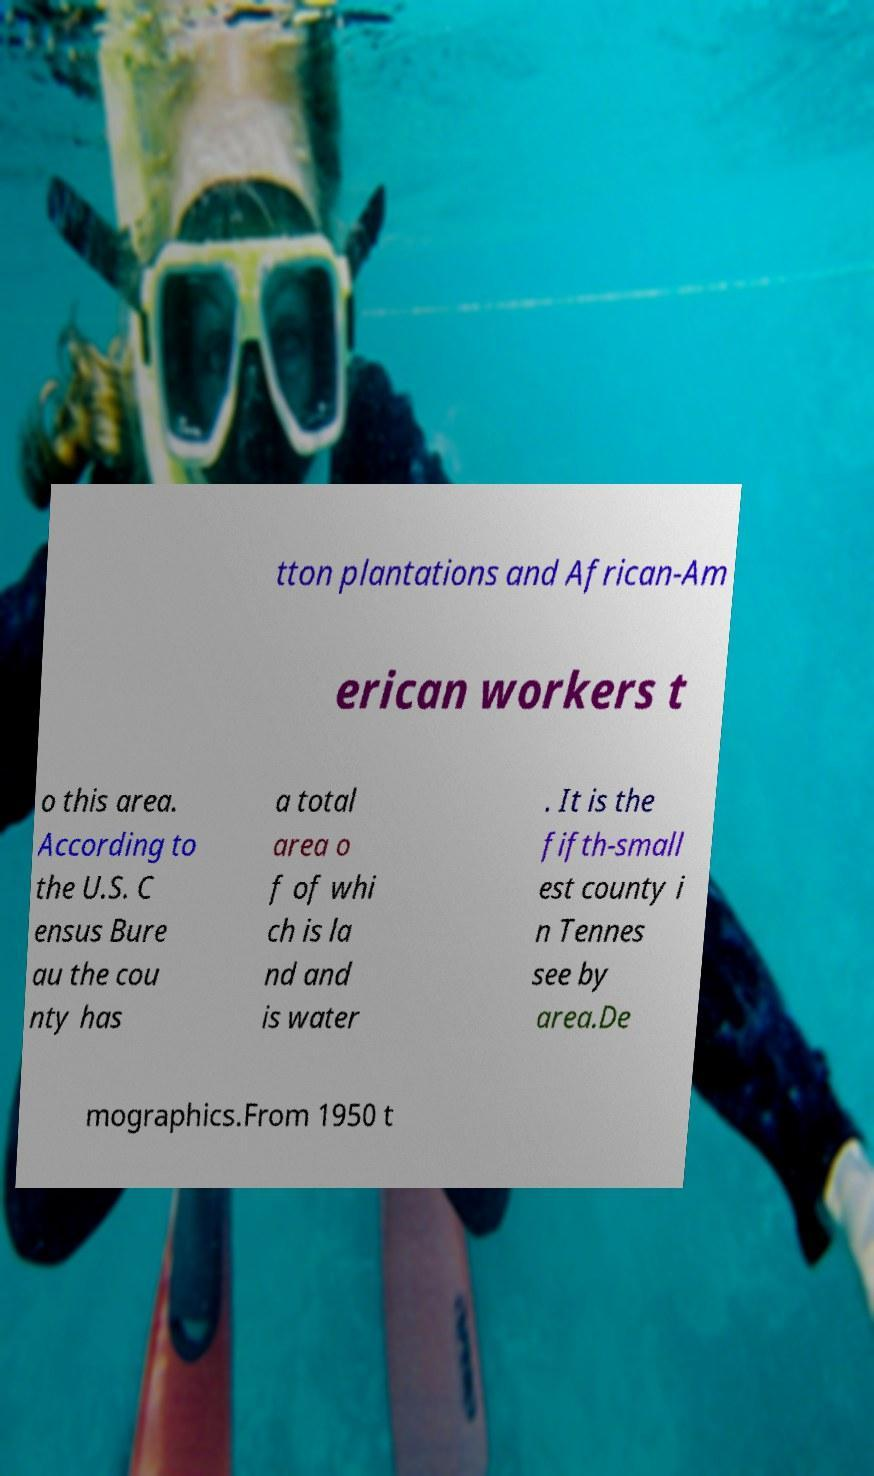I need the written content from this picture converted into text. Can you do that? tton plantations and African-Am erican workers t o this area. According to the U.S. C ensus Bure au the cou nty has a total area o f of whi ch is la nd and is water . It is the fifth-small est county i n Tennes see by area.De mographics.From 1950 t 